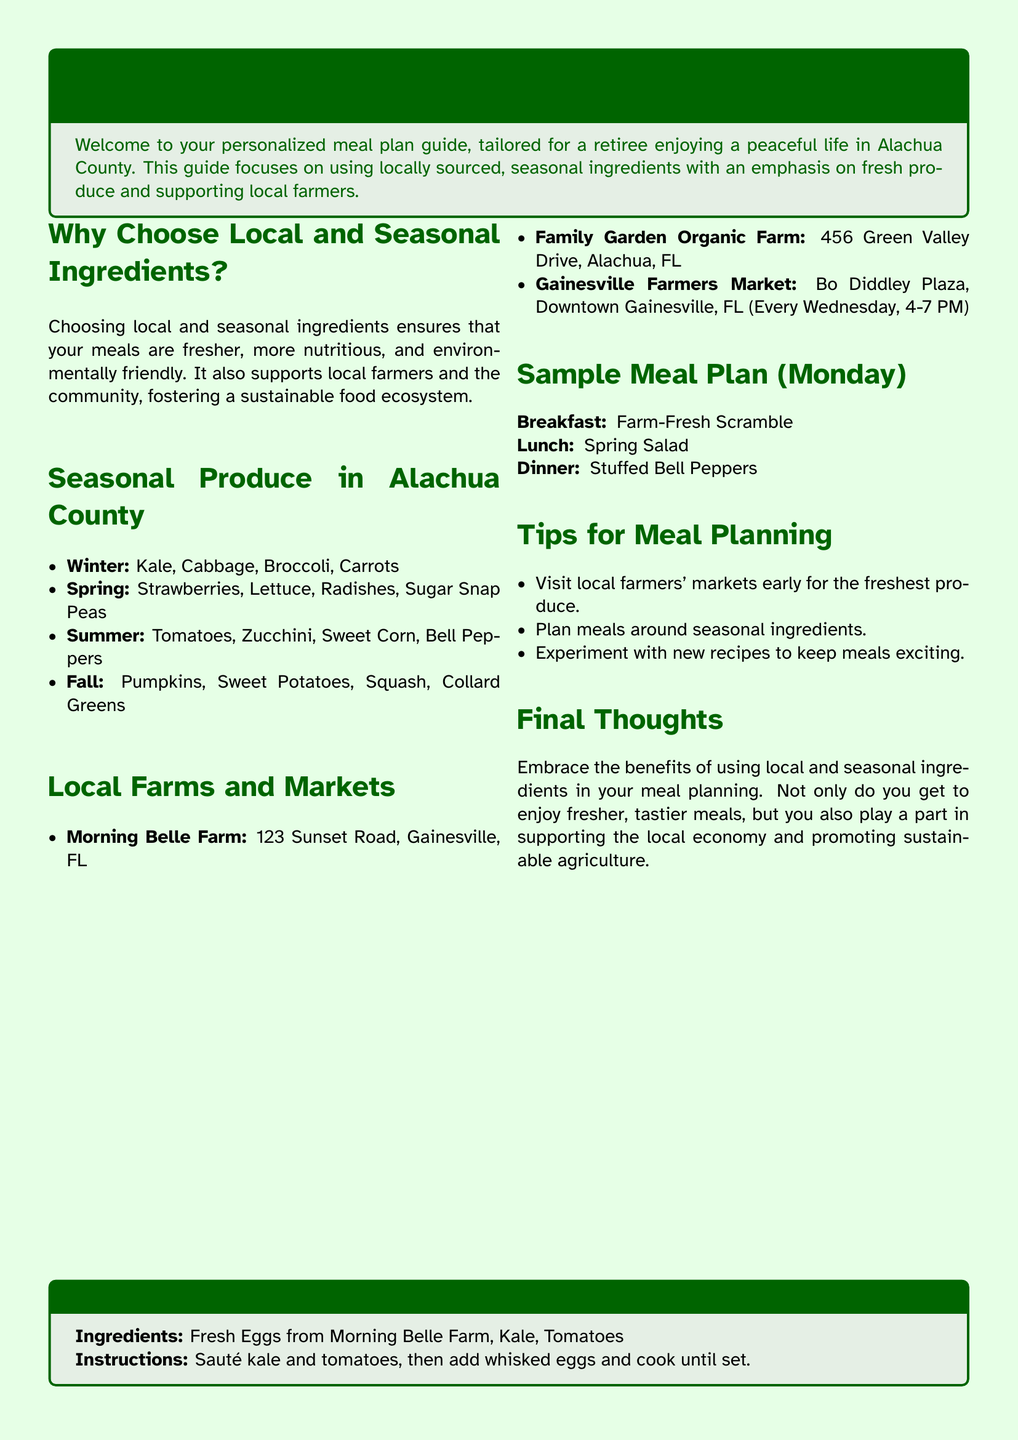What are the seasonal ingredients available in winter? The document lists Kale, Cabbage, Broccoli, and Carrots as the seasonal ingredients in winter.
Answer: Kale, Cabbage, Broccoli, Carrots Where is Morning Belle Farm located? The address for Morning Belle Farm is provided in the document, which is 123 Sunset Road, Gainesville, FL.
Answer: 123 Sunset Road, Gainesville, FL What is one benefit of choosing local ingredients? The document mentions several benefits, one of which is fresher meals.
Answer: Fresher meals What is the main focus of the meal plan? The meal plan primarily focuses on using locally sourced, seasonal ingredients.
Answer: Locally sourced, seasonal ingredients What type of meal is suggested for breakfast on Monday? The document outlines that a Farm-Fresh Scramble is suggested for breakfast on Monday.
Answer: Farm-Fresh Scramble What key activity is recommended for fresh produce? The document suggests visiting local farmers' markets early for the freshest produce.
Answer: Visiting local farmers' markets early What seasonal produce is available in the spring? The document lists Strawberries, Lettuce, Radishes, and Sugar Snap Peas as available in spring.
Answer: Strawberries, Lettuce, Radishes, Sugar Snap Peas How often does the Gainesville Farmers Market occur? The document indicates that the Gainesville Farmers Market occurs every Wednesday from 4-7 PM.
Answer: Every Wednesday, 4-7 PM 